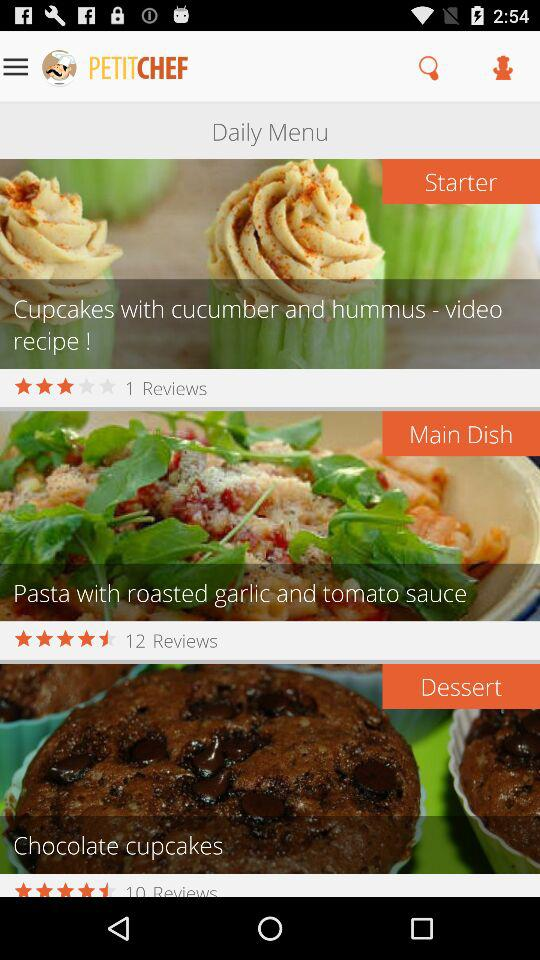What is the number of reviews for "Chocolate cupcakes"? The number of reviews for "Chocolate cupcakes" is 10. 